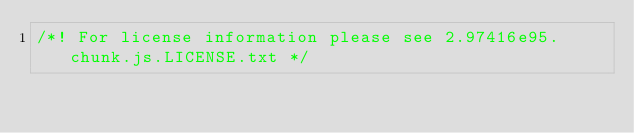<code> <loc_0><loc_0><loc_500><loc_500><_JavaScript_>/*! For license information please see 2.97416e95.chunk.js.LICENSE.txt */</code> 